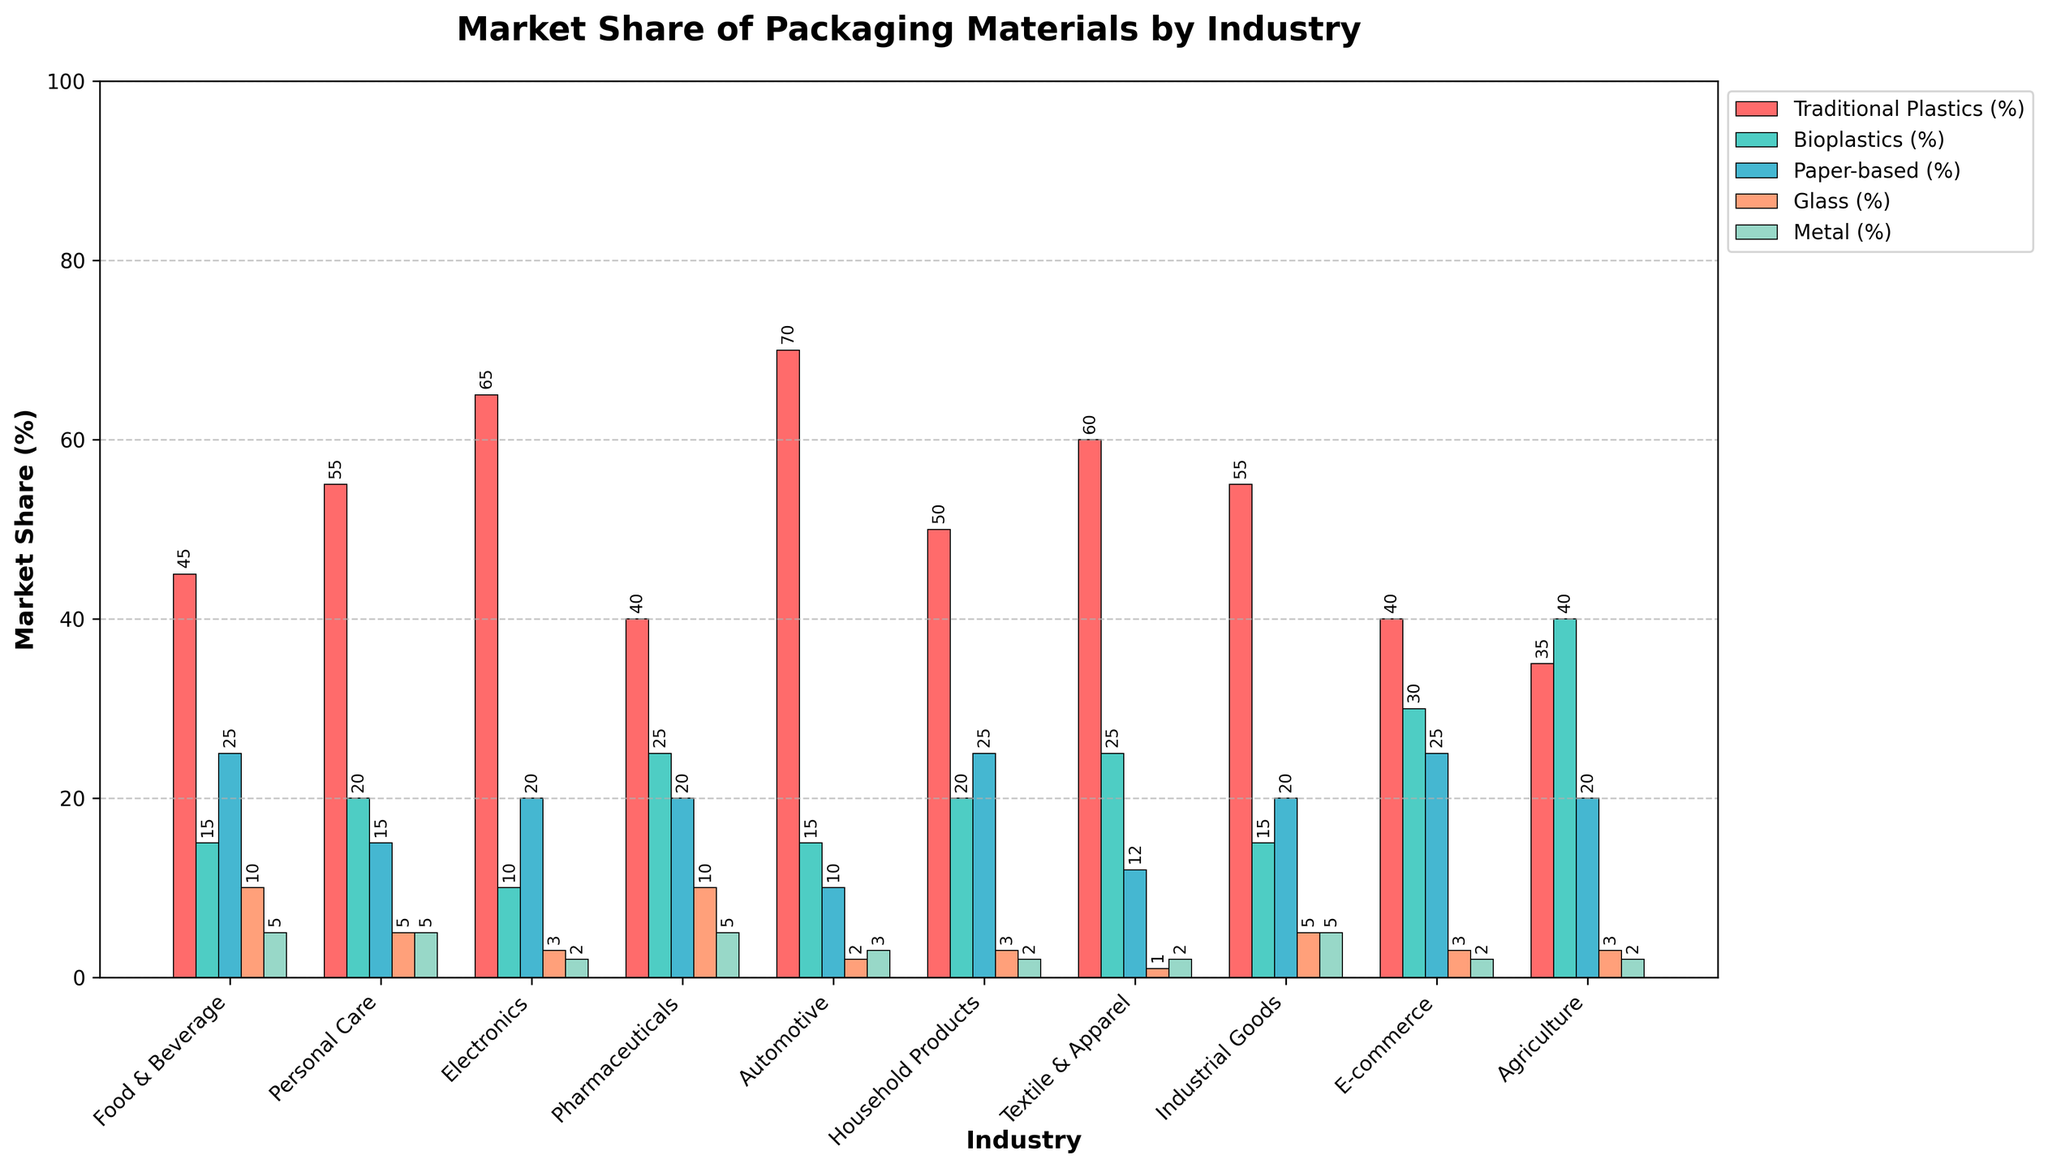Which industry has the highest market share of traditional plastics? Look for the tallest red bar among the industries. The industry with the highest market share of traditional plastics is the one with the tallest red bar.
Answer: Automotive Which industry uses the most bioplastics? Look for the industry with the tallest green bar, representing bioplastics.
Answer: Agriculture Out of the Food & Beverage and Personal Care industries, which one relies more on paper-based packaging? Compare the heights of the yellow bars for both Food & Beverage and Personal Care industries. The one with the taller yellow bar relies more on paper-based packaging.
Answer: Food & Beverage Which three industries have the highest market share of glass packaging combined? Identify and sum the market shares of glass packaging (orange bars) for each industry, then select the three industries with the highest combined total.
Answer: Pharmaceuticals, Food & Beverage, Personal Care What is the total market share of eco-friendly packaging materials (bioplastics, paper-based, glass, and metal) in electronics? Sum the market shares of bioplastics, paper-based, glass, and metal for the electronics industry (10% + 20% + 3% + 2%).
Answer: 35% Compare the use of metals between the Industrial Goods and Household Products industries. Which one uses more? Look at the height of the blue bars for Industrial Goods and Household Products. The industry with the taller blue bar uses more metals.
Answer: Both use the same Which industry has the lowest reliance on traditional plastics? Look for the industry with the shortest red bar.
Answer: Agriculture What is the average market share of traditional plastics across all industries? Add the market shares of traditional plastics for all industries (45 + 55 + 65 + 40 + 70 + 50 + 60 + 55 + 40 + 35) and divide by the number of industries (10).
Answer: 51.5% Which industry shows an equal market share for paper-based and metal packaging? Identify the industry where the heights of the yellow and blue bars are the same.
Answer: Industrial Goods 